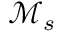Convert formula to latex. <formula><loc_0><loc_0><loc_500><loc_500>\mathcal { M } _ { s }</formula> 